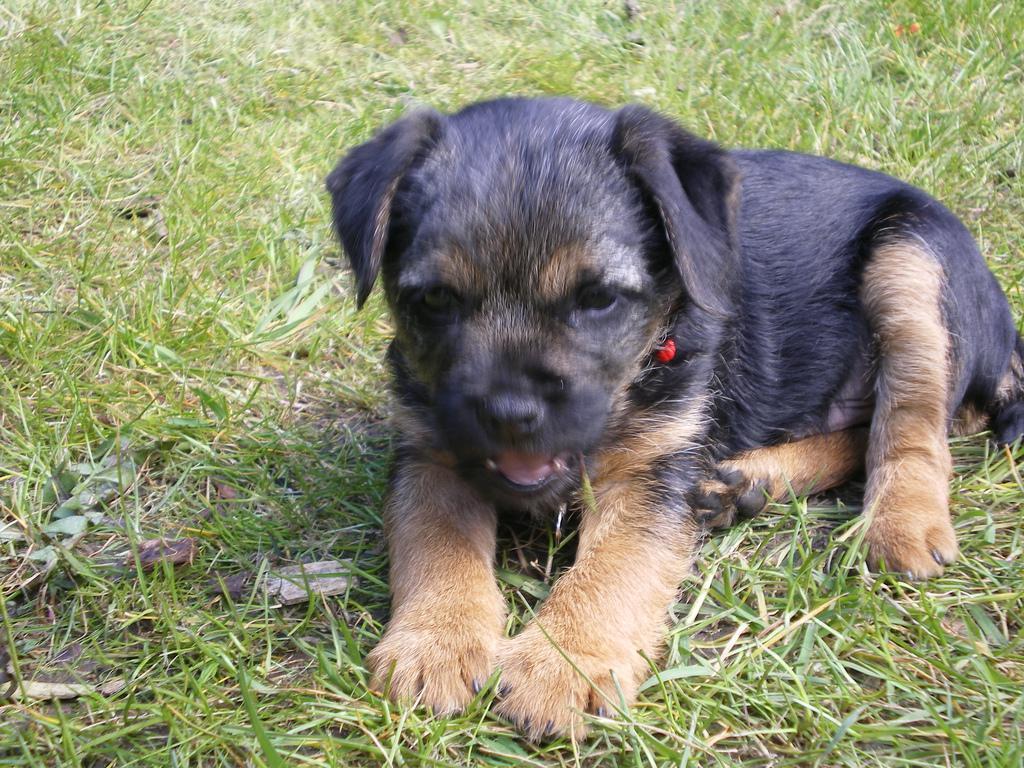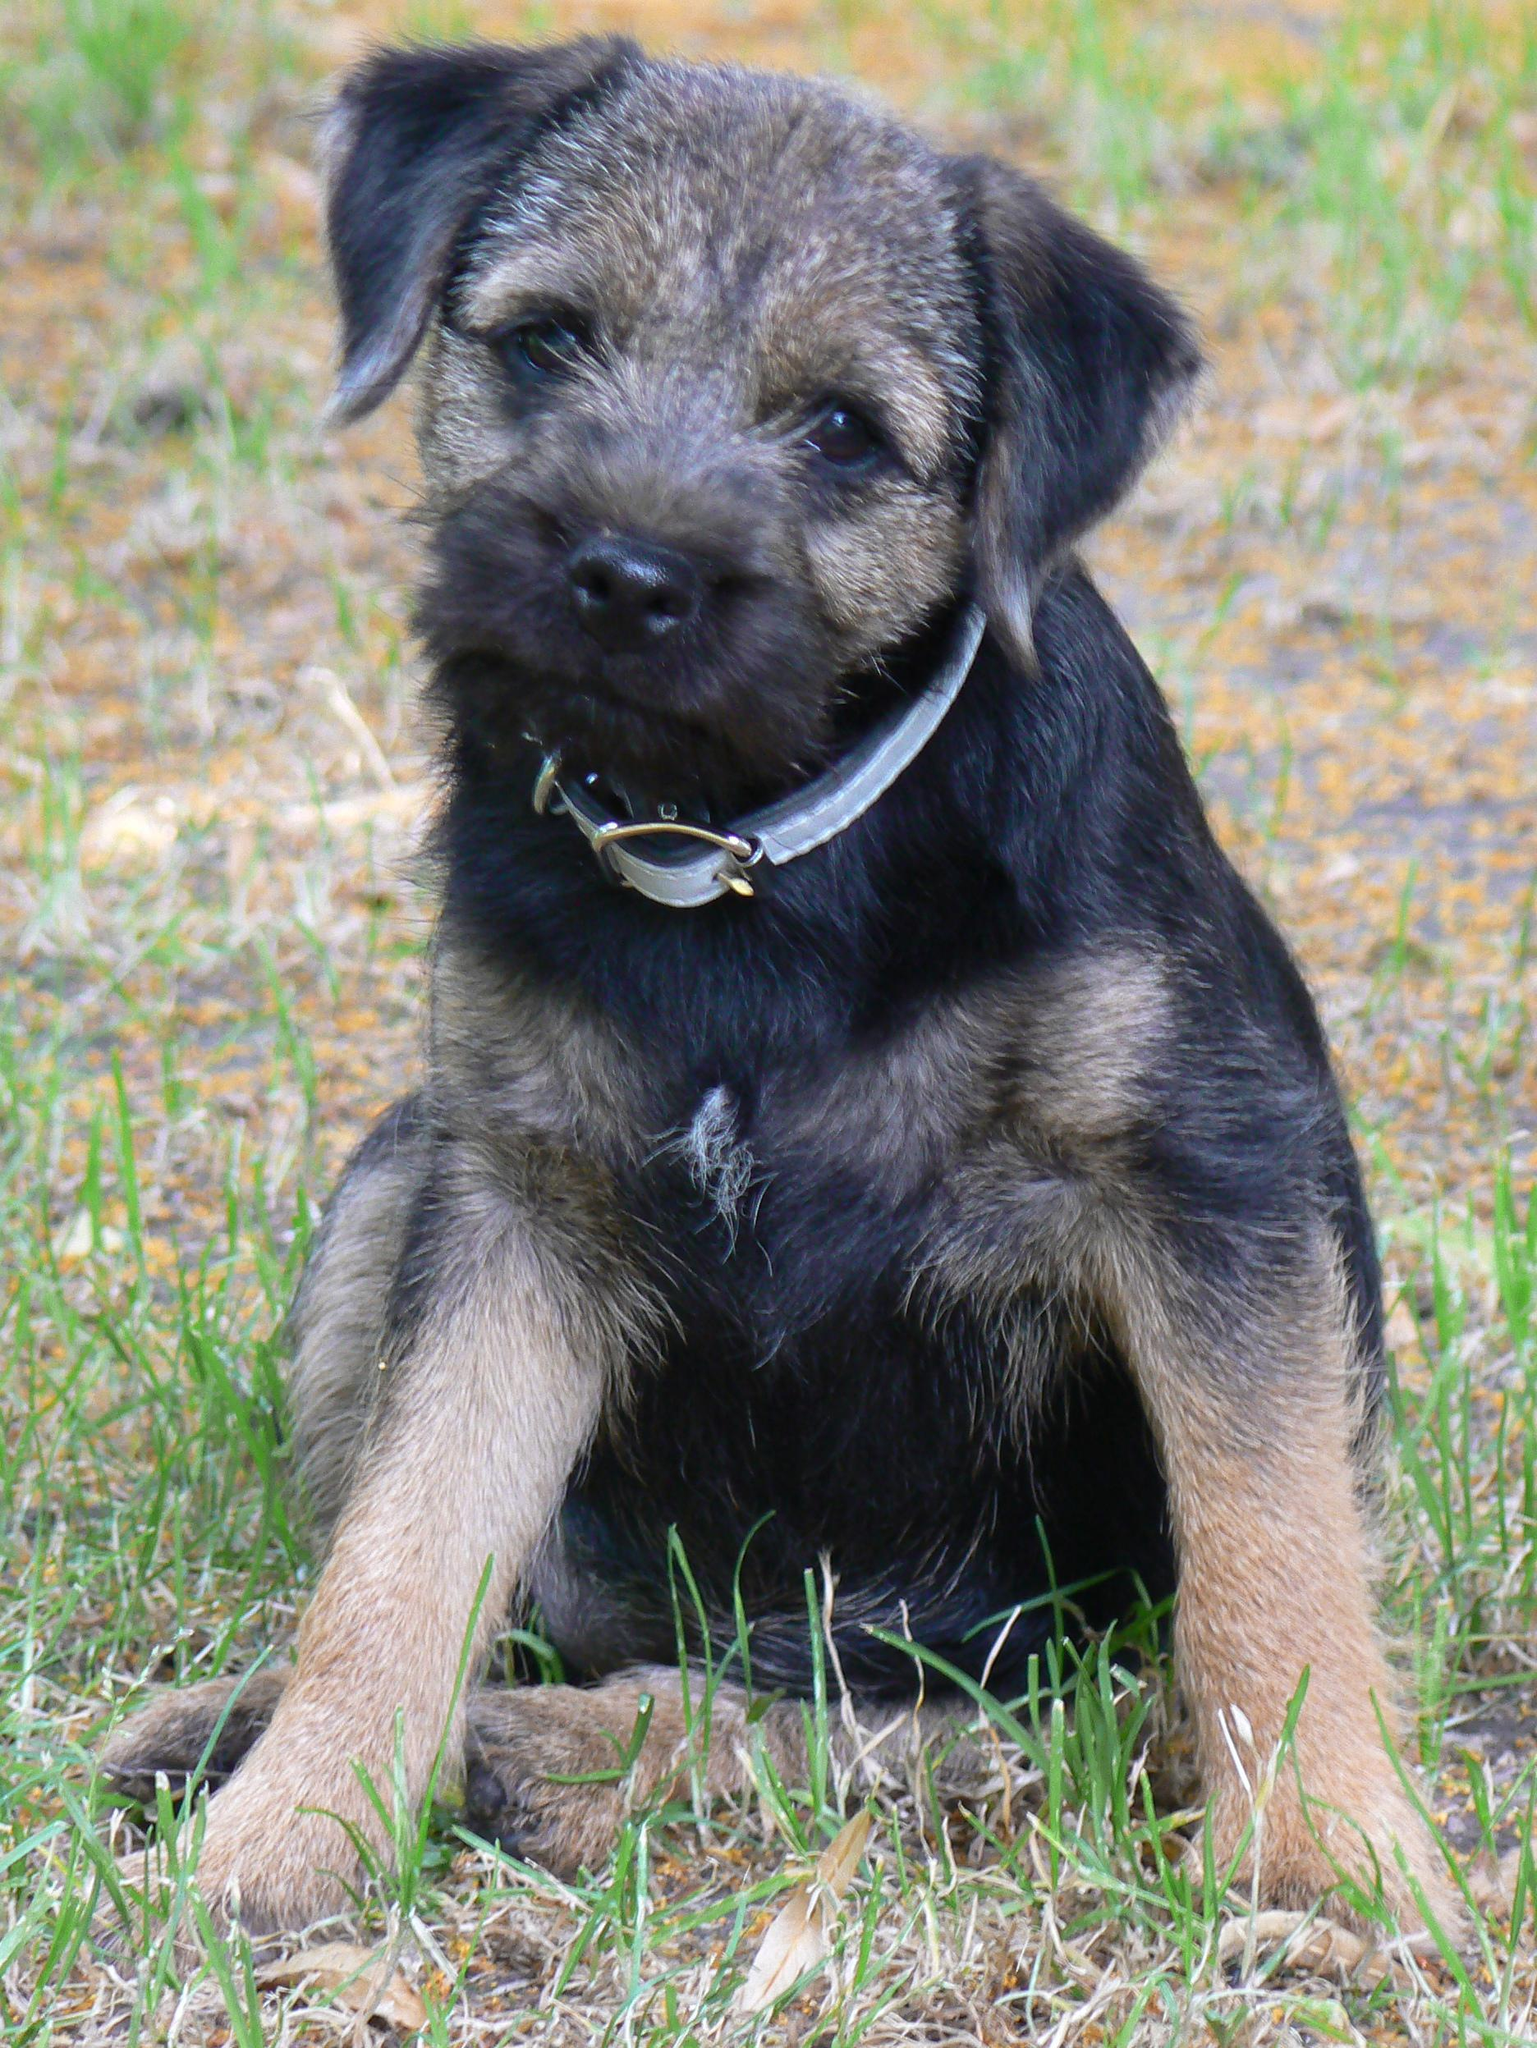The first image is the image on the left, the second image is the image on the right. Considering the images on both sides, is "The left image shows a dog with head and body in profile and its tail extended out, and the right image shows a puppy with its tail sticking out behind it." valid? Answer yes or no. No. The first image is the image on the left, the second image is the image on the right. Considering the images on both sides, is "One dog is standing in the grass." valid? Answer yes or no. No. 